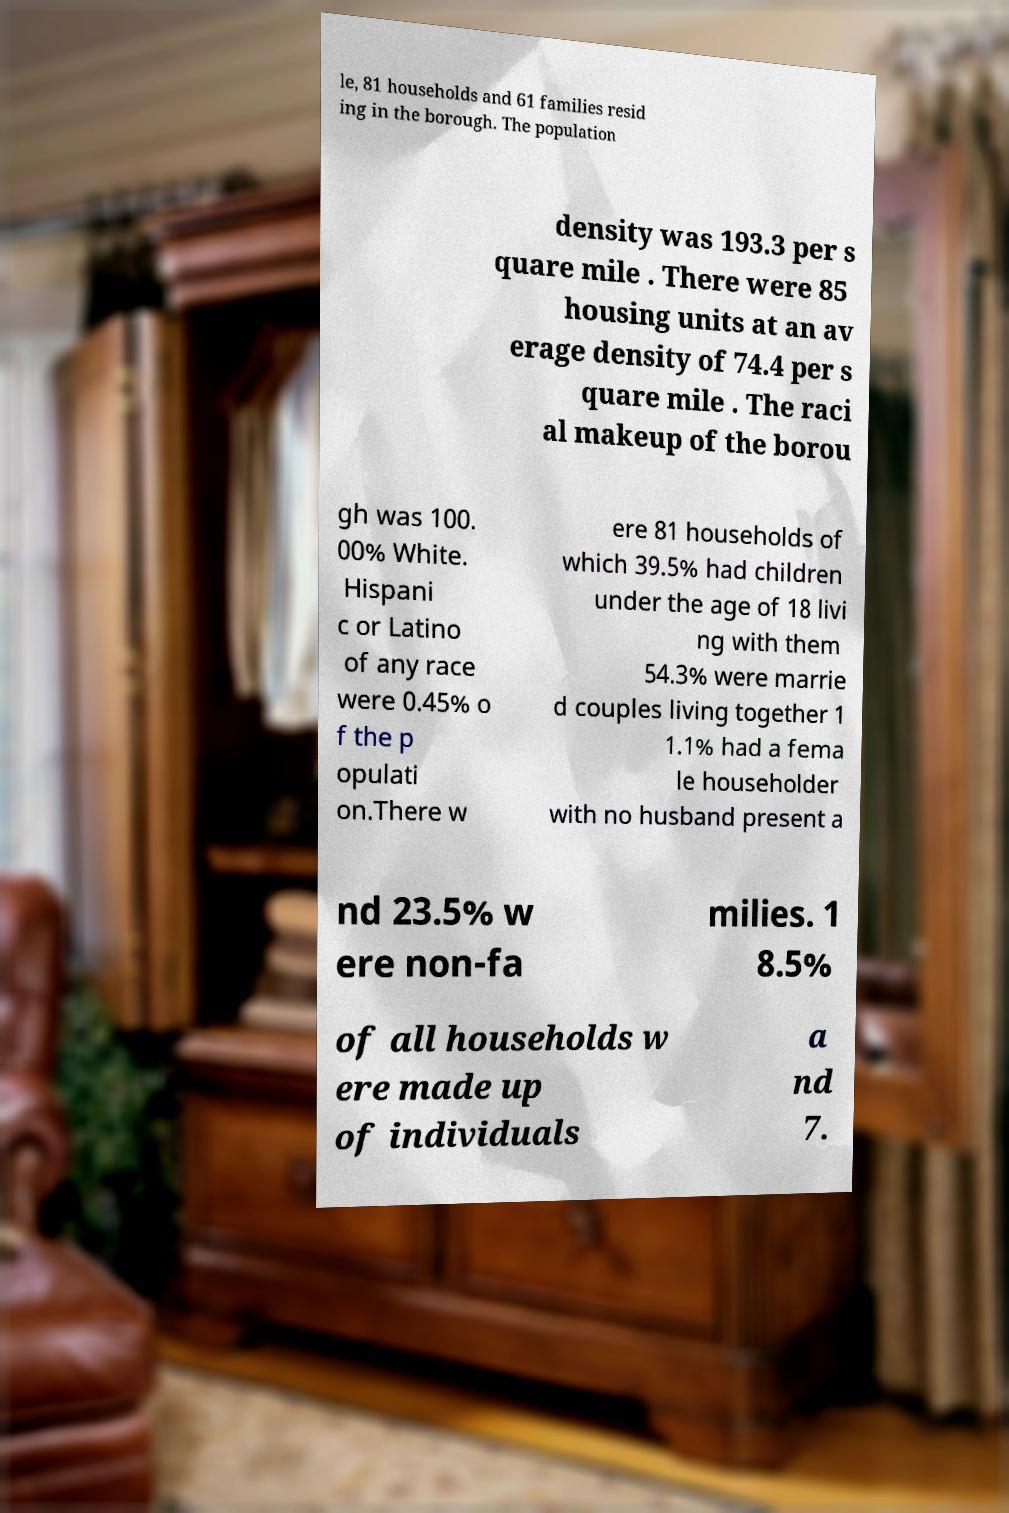Could you extract and type out the text from this image? le, 81 households and 61 families resid ing in the borough. The population density was 193.3 per s quare mile . There were 85 housing units at an av erage density of 74.4 per s quare mile . The raci al makeup of the borou gh was 100. 00% White. Hispani c or Latino of any race were 0.45% o f the p opulati on.There w ere 81 households of which 39.5% had children under the age of 18 livi ng with them 54.3% were marrie d couples living together 1 1.1% had a fema le householder with no husband present a nd 23.5% w ere non-fa milies. 1 8.5% of all households w ere made up of individuals a nd 7. 